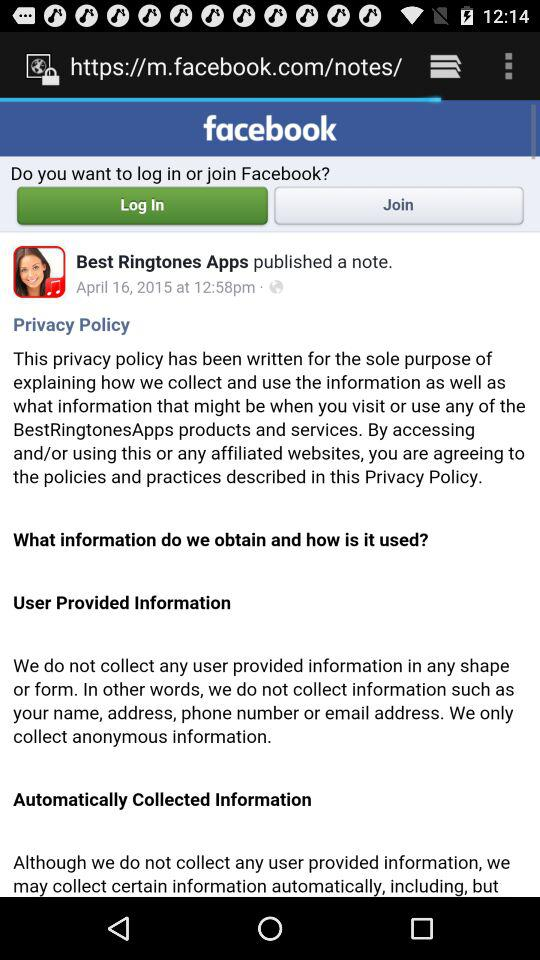What was the published date of a note by "Best Ringtones Apps"? The published date was April 16, 2015. 